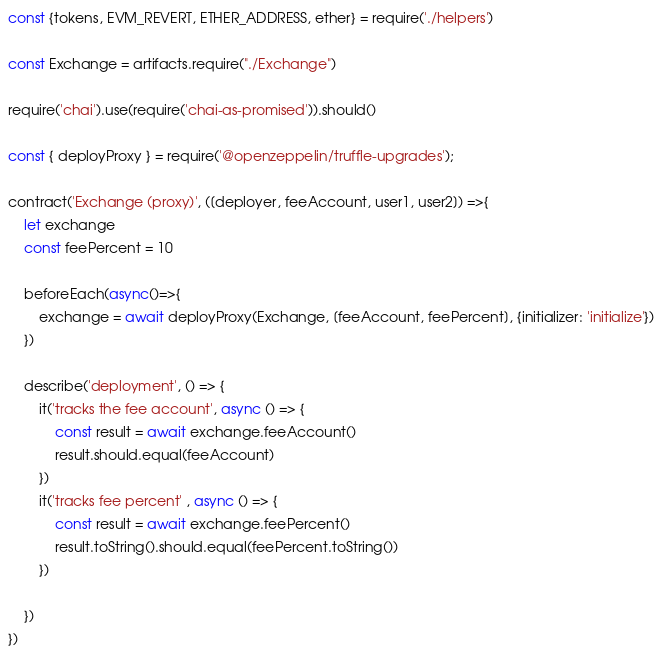Convert code to text. <code><loc_0><loc_0><loc_500><loc_500><_JavaScript_>const {tokens, EVM_REVERT, ETHER_ADDRESS, ether} = require('./helpers')

const Exchange = artifacts.require("./Exchange")

require('chai').use(require('chai-as-promised')).should()

const { deployProxy } = require('@openzeppelin/truffle-upgrades');

contract('Exchange (proxy)', ([deployer, feeAccount, user1, user2]) =>{
	let exchange
	const feePercent = 10

	beforeEach(async()=>{
		exchange = await deployProxy(Exchange, [feeAccount, feePercent], {initializer: 'initialize'})
	})

	describe('deployment', () => {
		it('tracks the fee account', async () => {
			const result = await exchange.feeAccount()
			result.should.equal(feeAccount)
		})
		it('tracks fee percent' , async () => {
			const result = await exchange.feePercent()
			result.toString().should.equal(feePercent.toString())
		})

	})
})</code> 